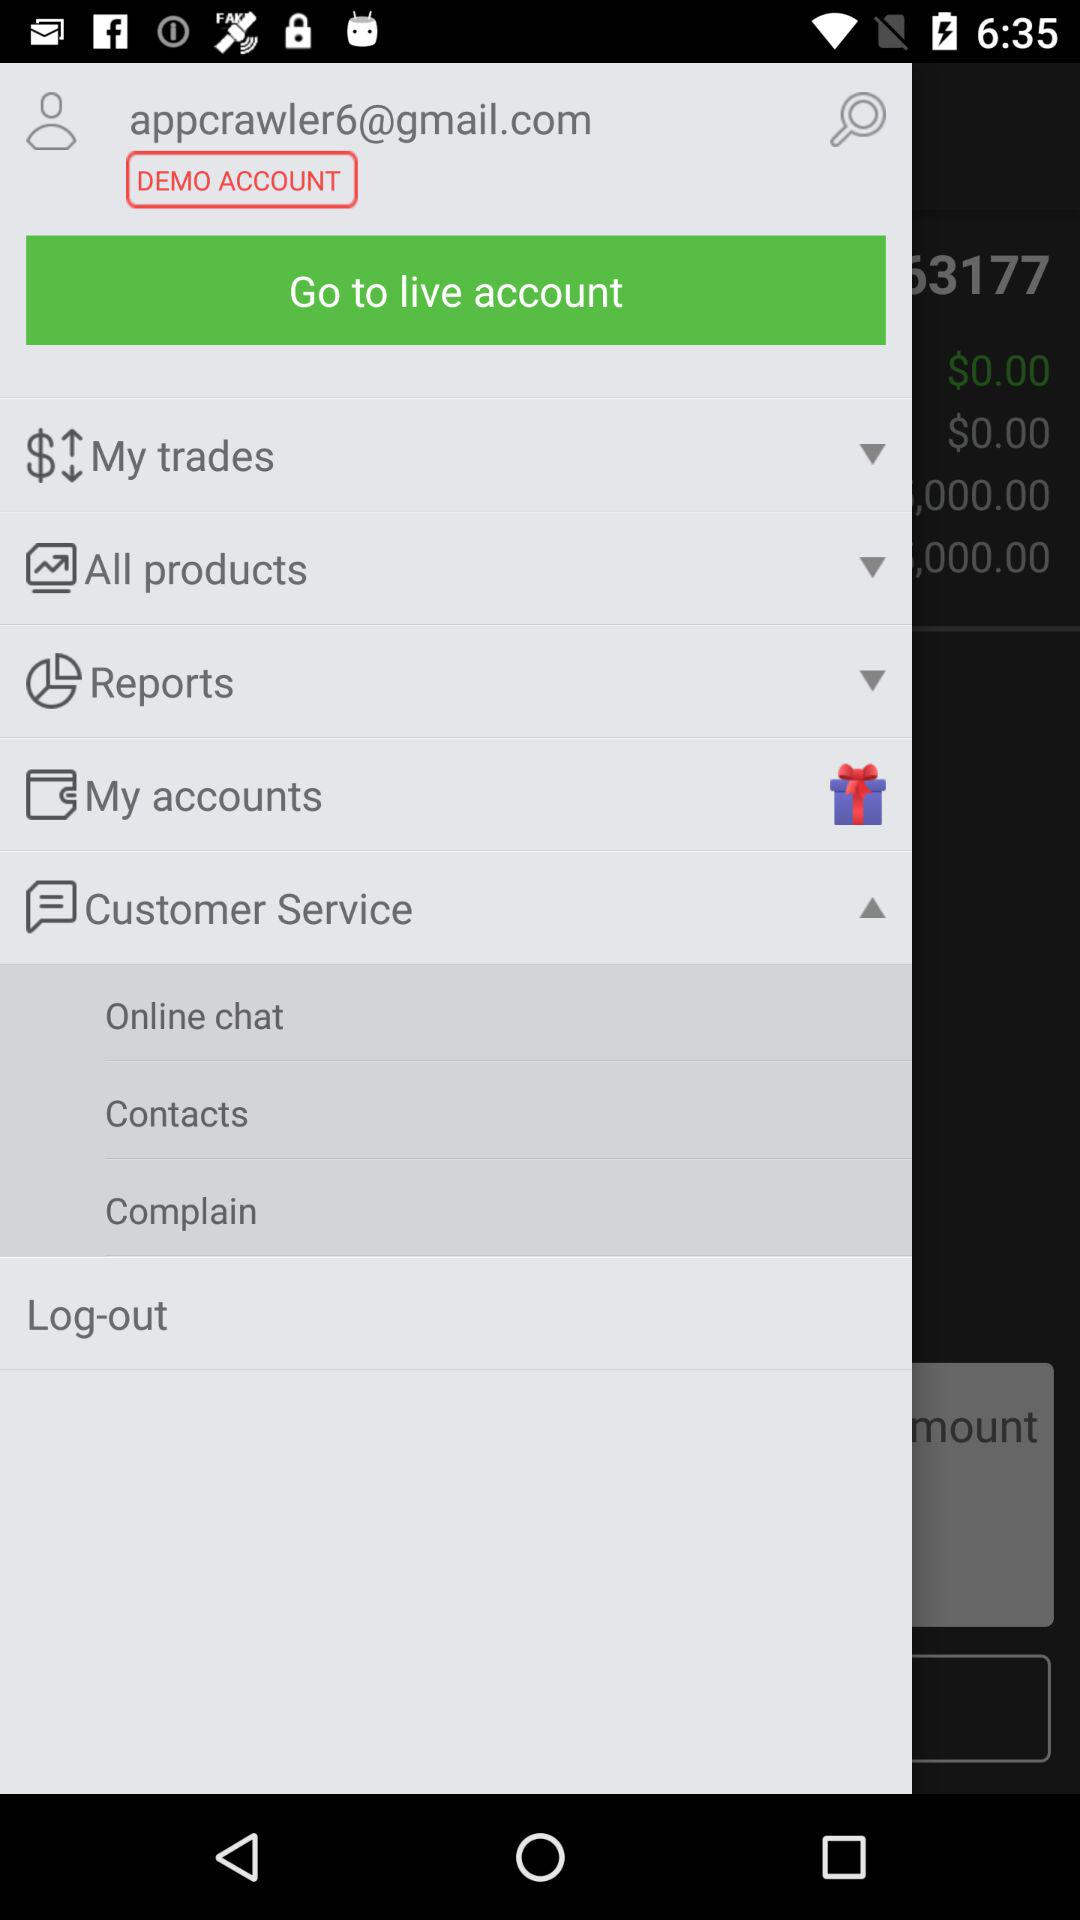What different options are given in "Customer Service"? The different options given in "Customer Service" are "Online chat", "Contacts" and "Complain". 